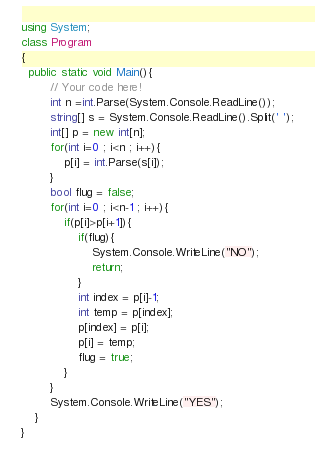<code> <loc_0><loc_0><loc_500><loc_500><_C#_>using System;
class Program
{
  public static void Main(){
        // Your code here!
        int n =int.Parse(System.Console.ReadLine());
        string[] s = System.Console.ReadLine().Split(' ');
        int[] p = new int[n];
        for(int i=0 ; i<n ; i++){
            p[i] = int.Parse(s[i]);
        }
        bool flug = false;
        for(int i=0 ; i<n-1 ; i++){
            if(p[i]>p[i+1]){
                if(flug){
                    System.Console.WriteLine("NO");
                    return;
                }
                int index = p[i]-1;
                int temp = p[index];
                p[index] = p[i];
                p[i] = temp;
                flug = true;
            }
        }
        System.Console.WriteLine("YES");
    }
}</code> 